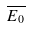<formula> <loc_0><loc_0><loc_500><loc_500>\overline { E _ { 0 } }</formula> 